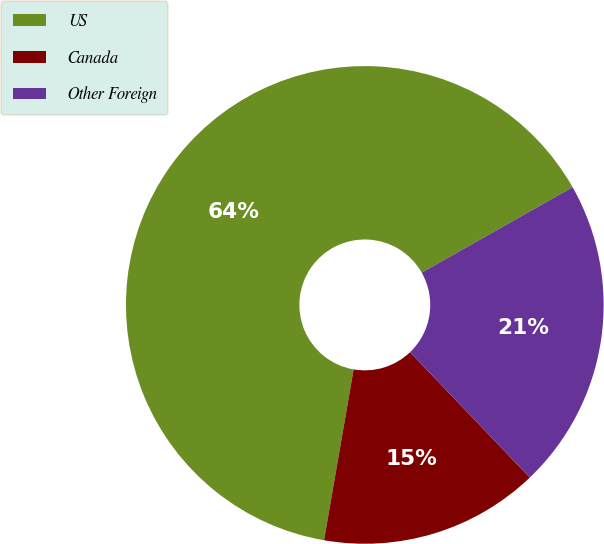Convert chart. <chart><loc_0><loc_0><loc_500><loc_500><pie_chart><fcel>US<fcel>Canada<fcel>Other Foreign<nl><fcel>64.07%<fcel>14.87%<fcel>21.06%<nl></chart> 